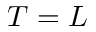Convert formula to latex. <formula><loc_0><loc_0><loc_500><loc_500>T = L</formula> 